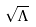<formula> <loc_0><loc_0><loc_500><loc_500>\sqrt { \Lambda }</formula> 